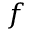<formula> <loc_0><loc_0><loc_500><loc_500>f</formula> 